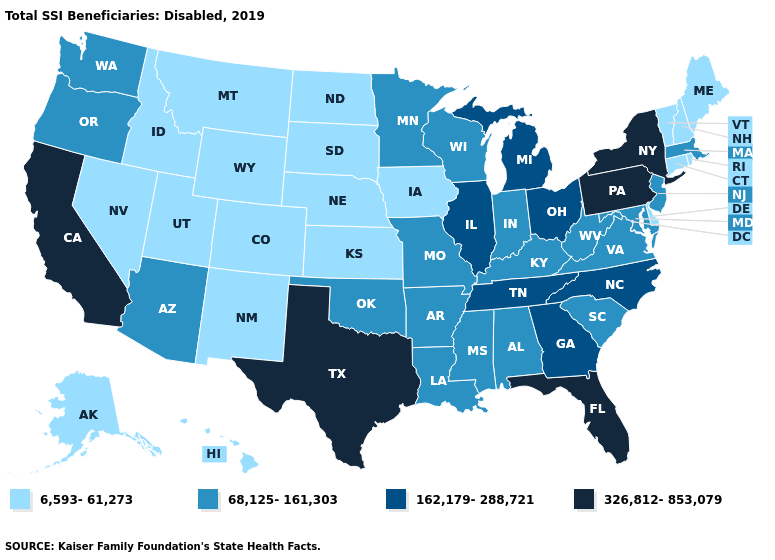What is the value of Maryland?
Short answer required. 68,125-161,303. Does Wyoming have the lowest value in the USA?
Be succinct. Yes. Does the map have missing data?
Write a very short answer. No. Among the states that border North Dakota , which have the lowest value?
Write a very short answer. Montana, South Dakota. What is the value of New Mexico?
Short answer required. 6,593-61,273. Does Florida have the highest value in the USA?
Quick response, please. Yes. Among the states that border Minnesota , does Wisconsin have the lowest value?
Give a very brief answer. No. What is the highest value in the USA?
Keep it brief. 326,812-853,079. Name the states that have a value in the range 162,179-288,721?
Answer briefly. Georgia, Illinois, Michigan, North Carolina, Ohio, Tennessee. Name the states that have a value in the range 162,179-288,721?
Concise answer only. Georgia, Illinois, Michigan, North Carolina, Ohio, Tennessee. Among the states that border Mississippi , which have the highest value?
Write a very short answer. Tennessee. How many symbols are there in the legend?
Be succinct. 4. Does Florida have a lower value than Vermont?
Quick response, please. No. What is the value of Iowa?
Be succinct. 6,593-61,273. What is the value of North Carolina?
Answer briefly. 162,179-288,721. 